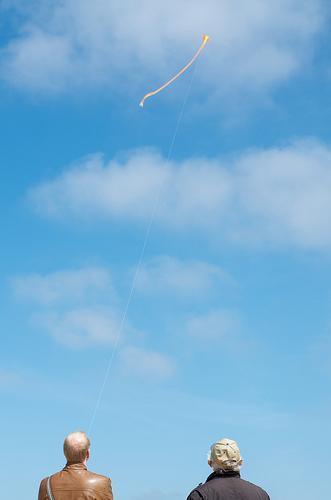How many kites are there?
Give a very brief answer. 1. 